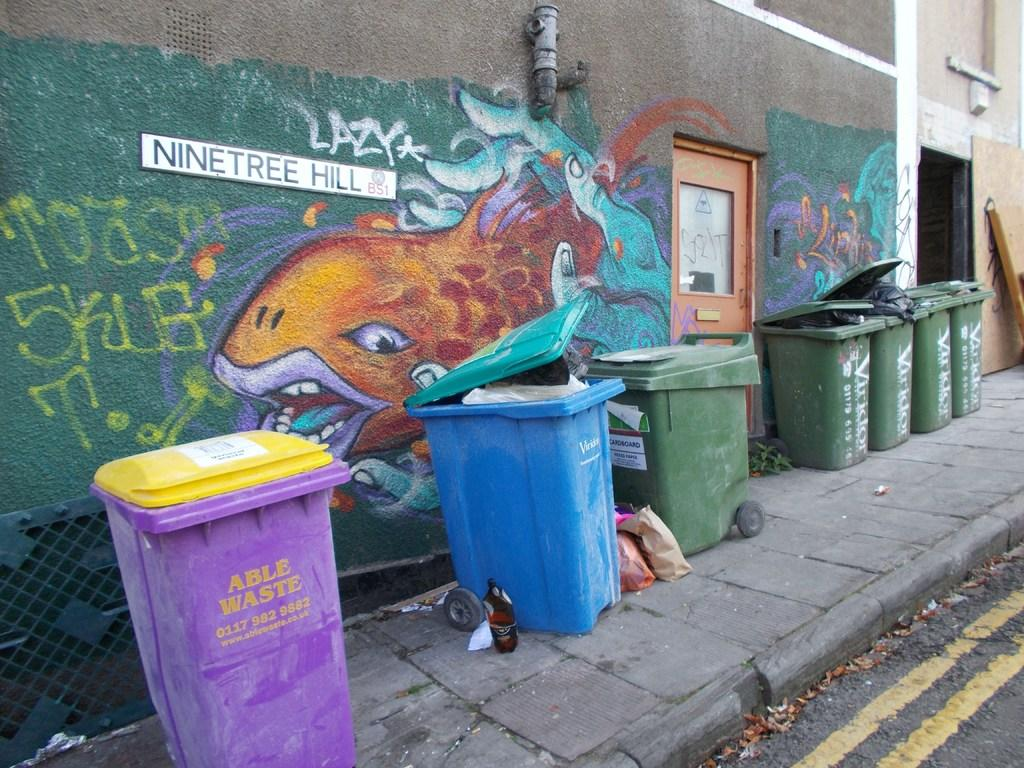<image>
Describe the image concisely. Purple garbage can next to a wall that says "Able Waste". 